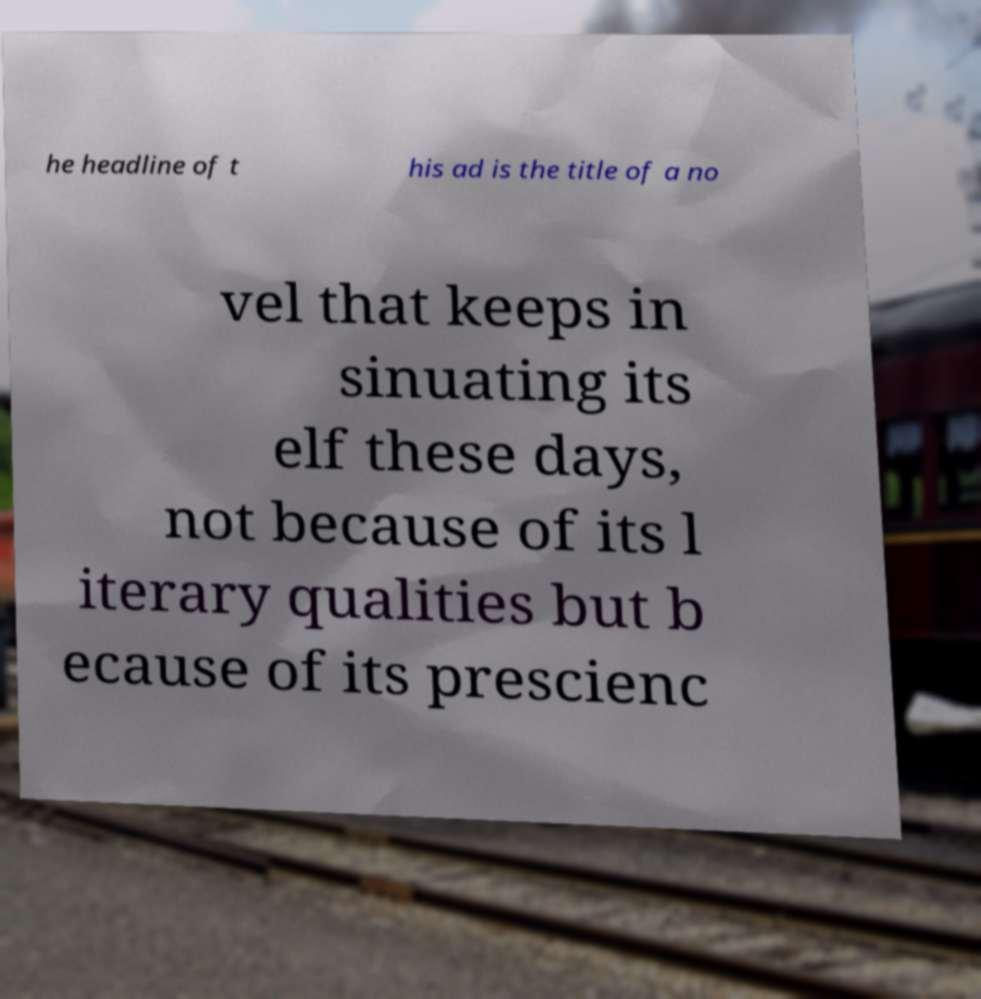Please identify and transcribe the text found in this image. he headline of t his ad is the title of a no vel that keeps in sinuating its elf these days, not because of its l iterary qualities but b ecause of its prescienc 